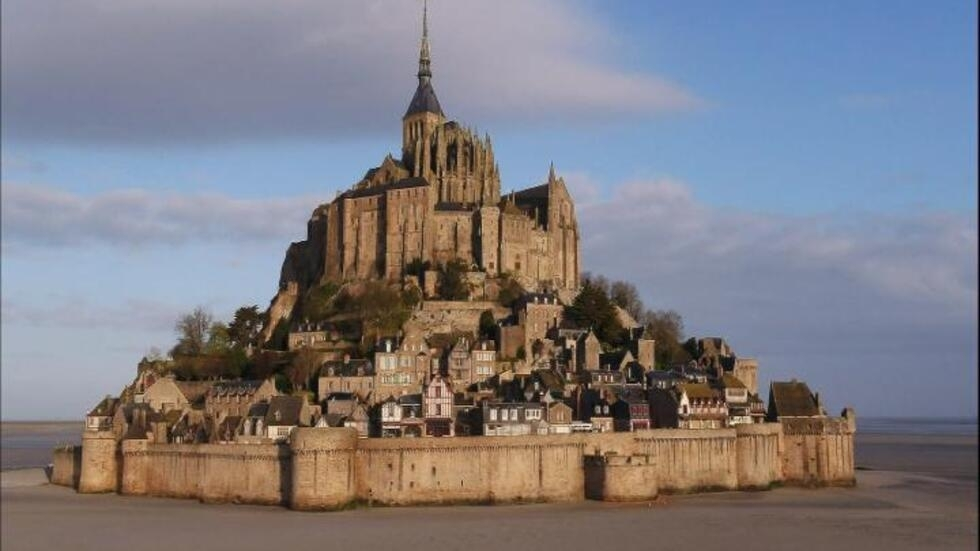Imagine a creative scenario that could take place in this location. Imagine Mont Saint Michel as the setting for a grand fantasy story. The abbey could serve as the ancient headquarters for a secret order of mystical guardians protecting humanity from malevolent forces. The village below, with its cobblestone streets and charming houses, could be populated by a mix of ordinary townsfolk and magical beings. The fortified walls could be a defense against mythical creatures that emerge when the tides retreat, creating a dramatic and enchanting tale set against the backdrop of this real-world marvel. 